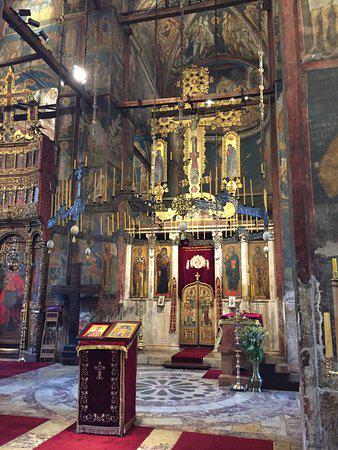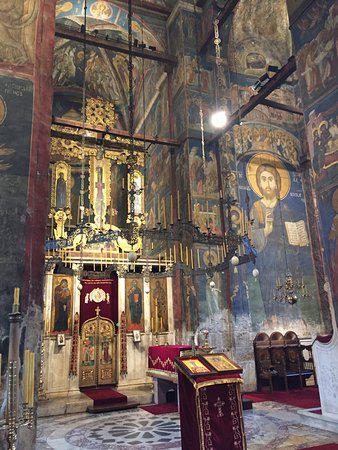The first image is the image on the left, the second image is the image on the right. Considering the images on both sides, is "There is a person in the image on the left." valid? Answer yes or no. No. 